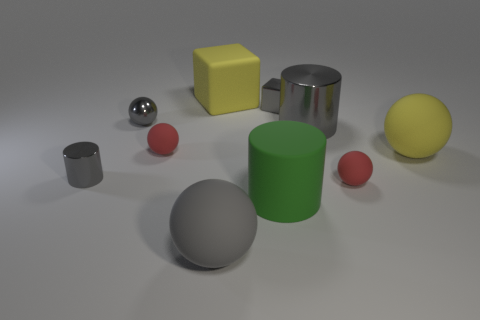How many gray cylinders must be subtracted to get 1 gray cylinders? 1 Subtract all rubber cylinders. How many cylinders are left? 2 Subtract 2 cylinders. How many cylinders are left? 1 Subtract all red balls. How many balls are left? 3 Subtract all cylinders. How many objects are left? 7 Add 2 tiny red things. How many tiny red things exist? 4 Subtract 0 red cubes. How many objects are left? 10 Subtract all cyan cylinders. Subtract all brown blocks. How many cylinders are left? 3 Subtract all red cylinders. How many green blocks are left? 0 Subtract all big purple rubber spheres. Subtract all tiny gray shiny spheres. How many objects are left? 9 